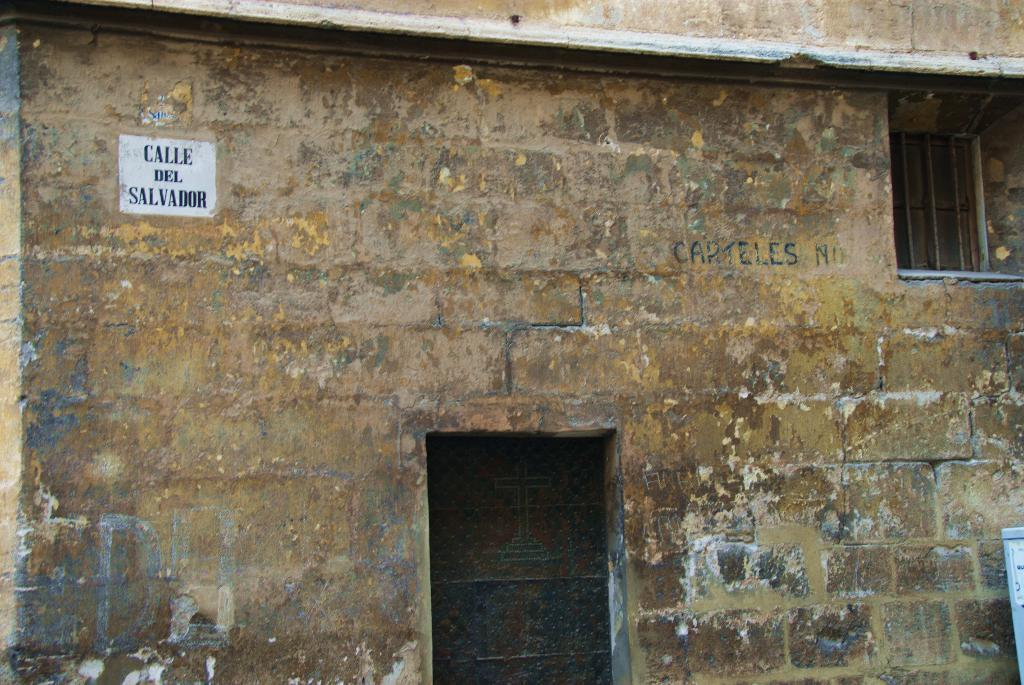What can be seen in the image? There is an object in the image. What architectural features are present in the image? There is a window and a door in the image. Are there any decorations or markings on the wall in the image? Yes, there is a sticker on the wall in the image. What effect does the vein have on the object in the image? There is no vein present in the image, so it cannot have any effect on the object. 